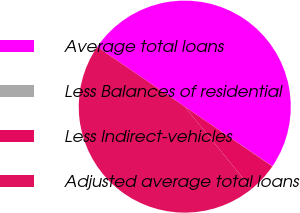<chart> <loc_0><loc_0><loc_500><loc_500><pie_chart><fcel>Average total loans<fcel>Less Balances of residential<fcel>Less Indirect-vehicles<fcel>Adjusted average total loans<nl><fcel>49.98%<fcel>0.02%<fcel>4.61%<fcel>45.39%<nl></chart> 